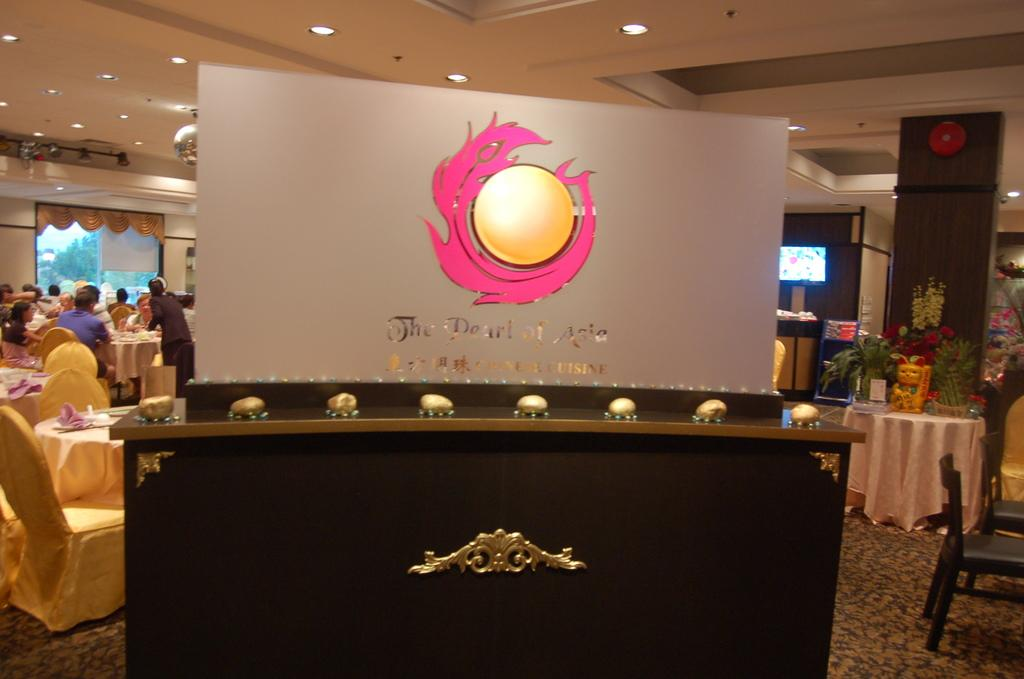What is the main object in the image? There is a table in the image. What is placed on the table? A banner is placed on the table. Can you describe the people in the background of the image? There are people sitting on chairs in the background of the image. What type of shade is being provided by the elbow in the image? There is no mention of an elbow or shade in the image. 